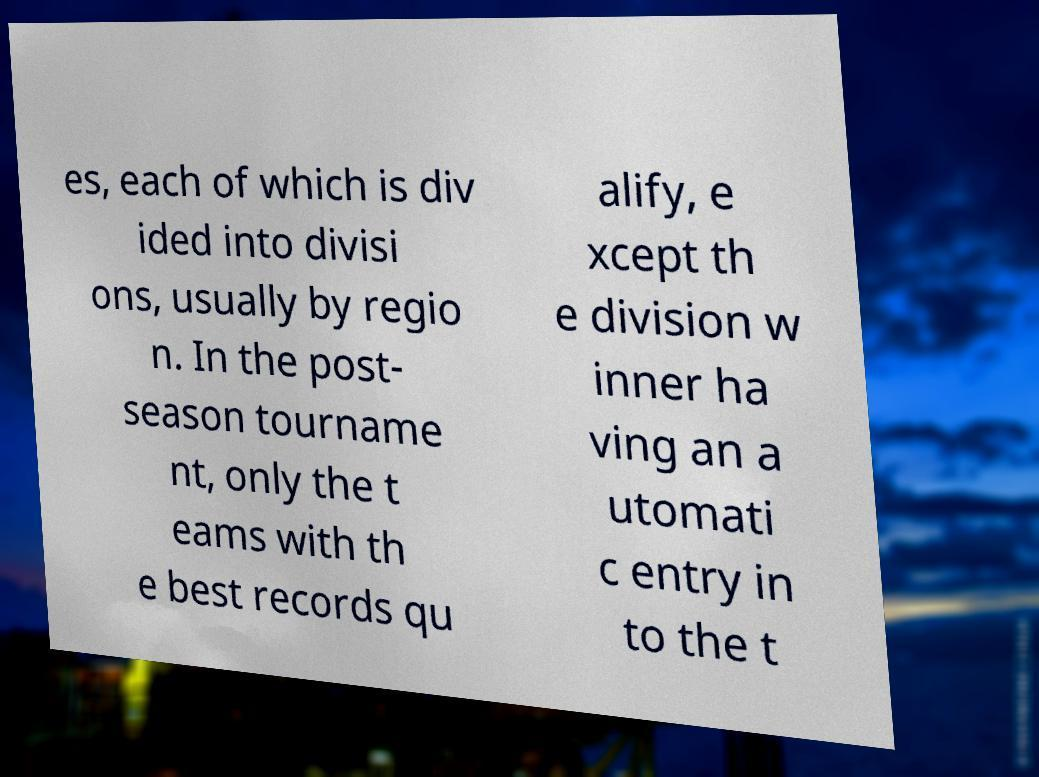Can you read and provide the text displayed in the image?This photo seems to have some interesting text. Can you extract and type it out for me? es, each of which is div ided into divisi ons, usually by regio n. In the post- season tourname nt, only the t eams with th e best records qu alify, e xcept th e division w inner ha ving an a utomati c entry in to the t 